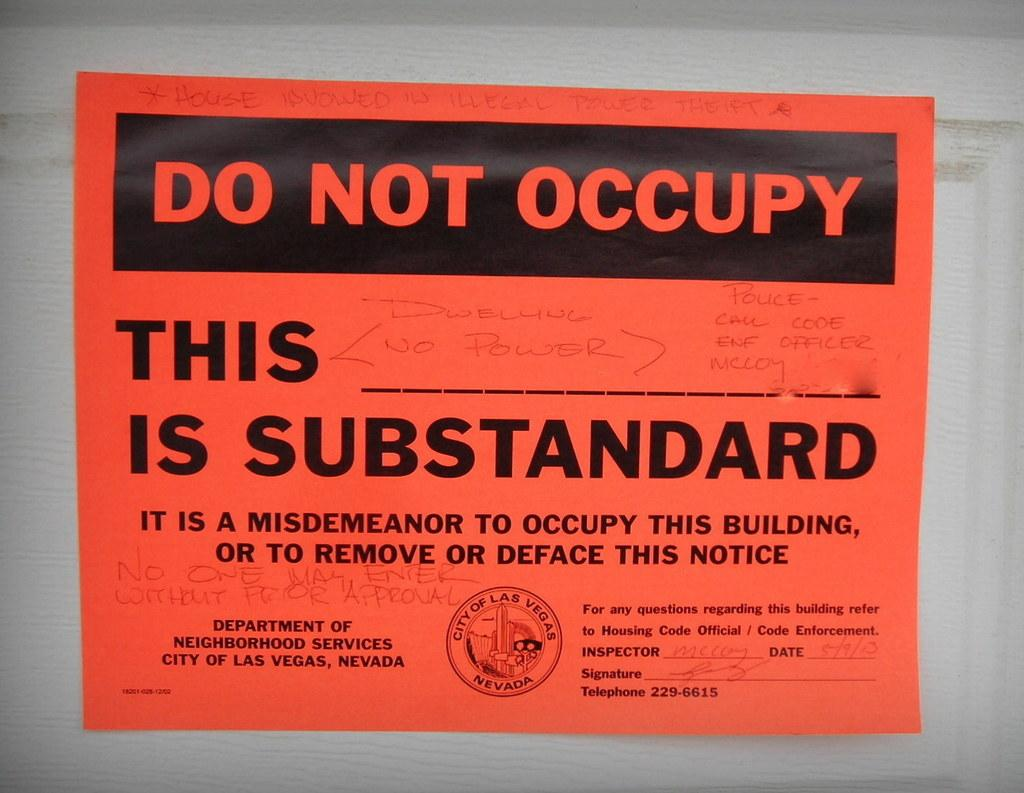<image>
Summarize the visual content of the image. An orange warning sign that states "Do Not Occupy" in bold lettering. 